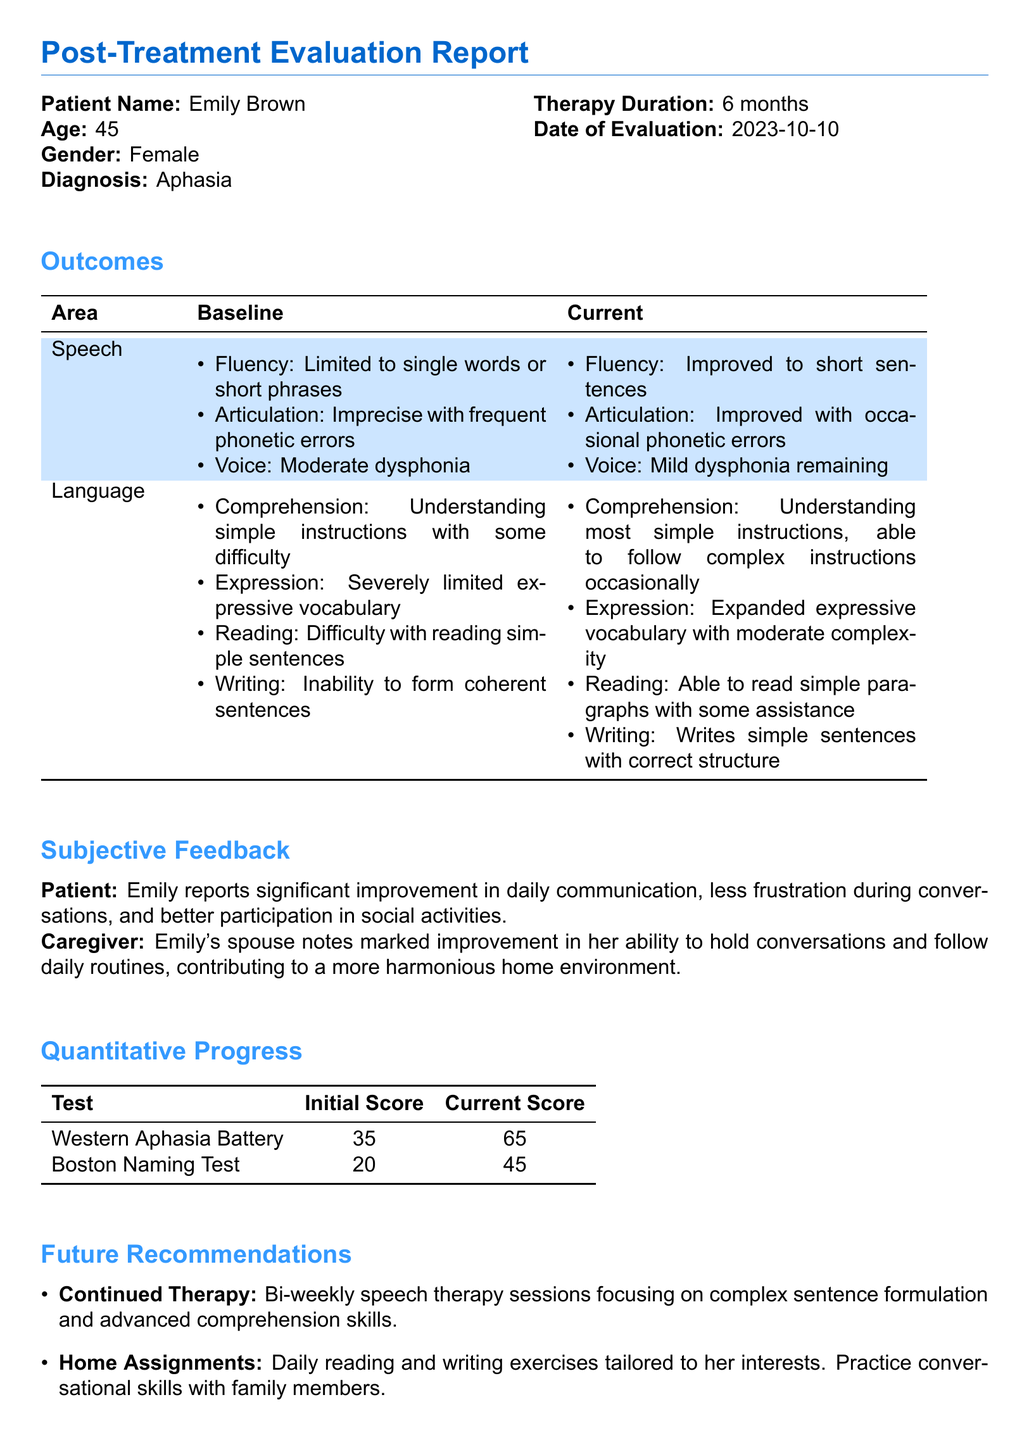What is the patient's name? The patient's name is listed at the beginning of the document under "Patient Name".
Answer: Emily Brown What is the age of the patient? The age of the patient is mentioned alongside her name in the document.
Answer: 45 What was the duration of the therapy? The duration of therapy is provided in the section detailing the patient's therapy information.
Answer: 6 months What was the initial score on the Western Aphasia Battery? The initial score for the Western Aphasia Battery is recorded in the quantitative progress section.
Answer: 35 What specific improvement did Emily report? Emily's subjective feedback regarding her improvement in communication is documented.
Answer: Significant improvement in daily communication In which area did articulation improve? The outcomes table notes improvements in articulation under the speech category.
Answer: Improved with occasional phonetic errors What type of therapy is recommended bi-weekly? The future recommendations section specifies the frequency and focus of the therapy needed for the patient.
Answer: Speech therapy sessions focusing on complex sentence formulation What does the caregiver note about Emily? The caregiver's feedback provides insight into the observed changes in behavior and capacity.
Answer: Marked improvement in her ability to hold conversations When is the follow-up evaluation scheduled? The follow-up evaluation timeline is outlined in the future recommendations section.
Answer: After 3 months 